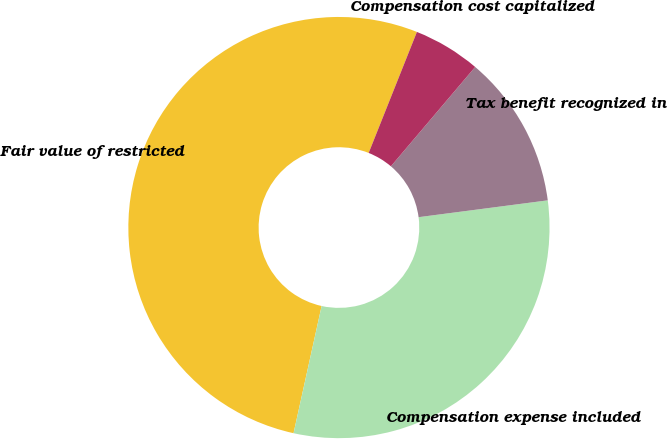<chart> <loc_0><loc_0><loc_500><loc_500><pie_chart><fcel>Fair value of restricted<fcel>Compensation expense included<fcel>Tax benefit recognized in<fcel>Compensation cost capitalized<nl><fcel>52.58%<fcel>30.52%<fcel>11.74%<fcel>5.16%<nl></chart> 